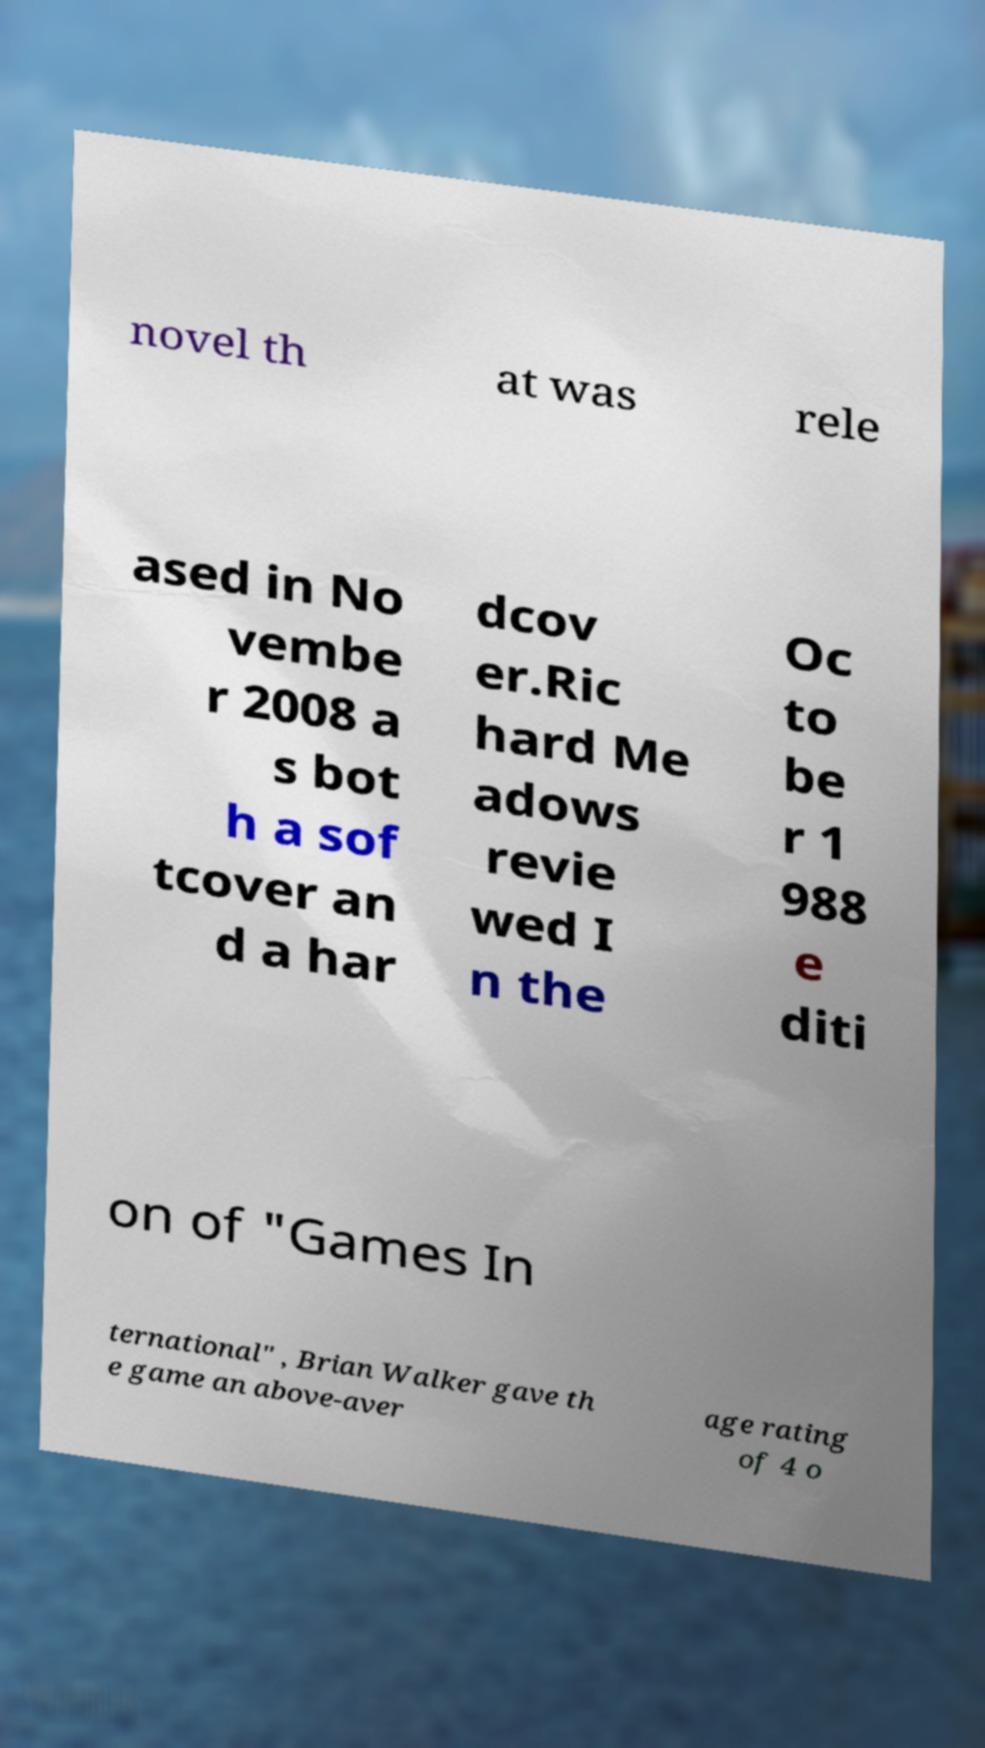I need the written content from this picture converted into text. Can you do that? novel th at was rele ased in No vembe r 2008 a s bot h a sof tcover an d a har dcov er.Ric hard Me adows revie wed I n the Oc to be r 1 988 e diti on of "Games In ternational" , Brian Walker gave th e game an above-aver age rating of 4 o 